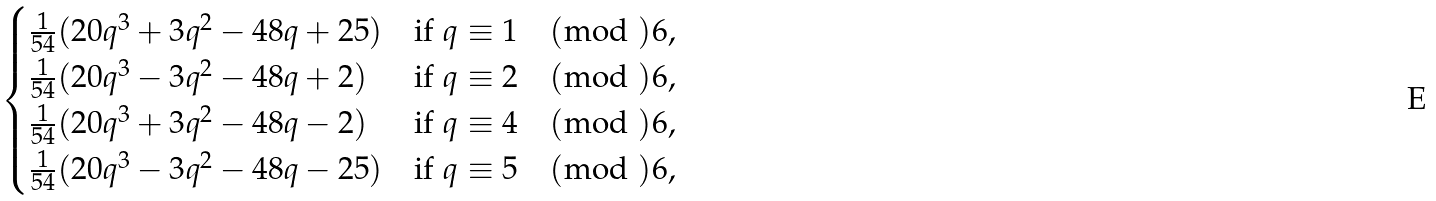<formula> <loc_0><loc_0><loc_500><loc_500>\begin{cases} \frac { 1 } { 5 4 } ( 2 0 q ^ { 3 } + 3 q ^ { 2 } - 4 8 q + 2 5 ) & \text {if $q \equiv 1 \pmod{ }6$,} \\ \frac { 1 } { 5 4 } ( 2 0 q ^ { 3 } - 3 q ^ { 2 } - 4 8 q + 2 ) & \text {if $q \equiv 2 \pmod{ }6$,} \\ \frac { 1 } { 5 4 } ( 2 0 q ^ { 3 } + 3 q ^ { 2 } - 4 8 q - 2 ) & \text {if $q \equiv 4 \pmod{ }6$,} \\ \frac { 1 } { 5 4 } ( 2 0 q ^ { 3 } - 3 q ^ { 2 } - 4 8 q - 2 5 ) & \text {if $q \equiv 5 \pmod{ }6$,} \end{cases}</formula> 